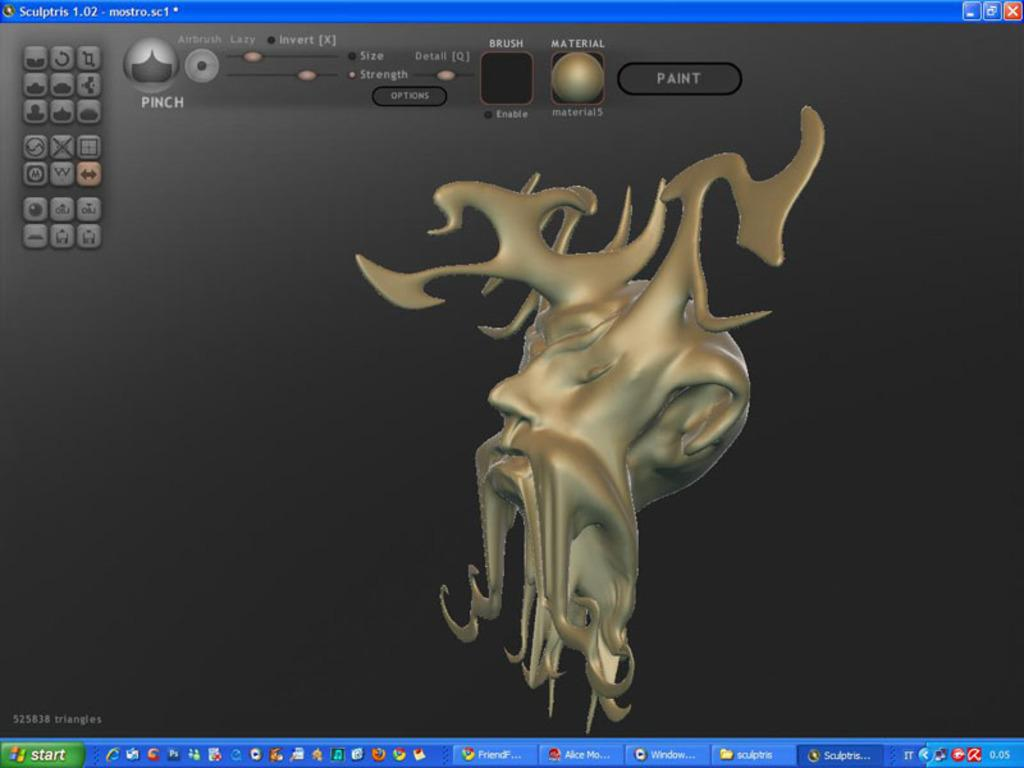<image>
Provide a brief description of the given image. A screen showing a software creation of strange mythical golden head, has the button 'Paint' above the head. 